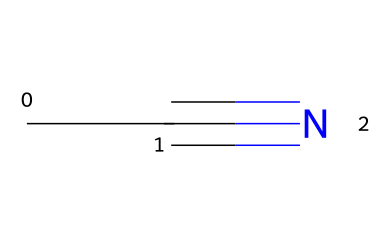What is the molecular formula of acetonitrile? The SMILES representation CC#N indicates that there are two carbon atoms (C) and one nitrogen atom (N), leading to the molecular formula C2H3N.
Answer: C2H3N How many total atoms are present in acetonitrile? From the molecular formula C2H3N, we can count 2 carbon, 3 hydrogen, and 1 nitrogen atom, which adds up to a total of 6 atoms.
Answer: 6 What type of functional group is present in acetonitrile? The presence of the cyano group (-C≡N) in the structure indicates that acetonitrile is classified as a nitrile.
Answer: nitrile What is the degree of unsaturation in acetonitrile? For the formula C2H3N, we can use the formula (2C + 2 - H)/2 to calculate the degree of unsaturation, resulting in 1, indicating one double bond or one ring.
Answer: 1 Based on its structure, what type of bond connects the carbon and nitrogen in acetonitrile? The SMILES CC#N indicates a triple bond (#) between carbon and nitrogen, which is characteristic of nitriles.
Answer: triple bond What is the primary use of acetonitrile in cleaning products? Acetonitrile is commonly used as a solvent due to its ability to dissolve various substances, making it effective in cleaning applications.
Answer: solvent 